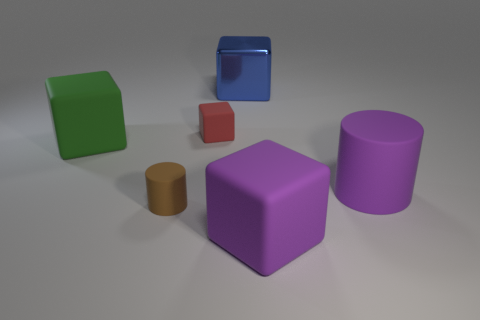What materials do the objects appear to be made from? The objects in the image seem to have different materials. The green and the red cubes have a matte finish suggesting a solid, possibly plastic or painted wooden material. The blue cube has a transparent, glass-like appearance. The cylinders and the purple cube appear to have a matte, non-reflective surface, also indicative of a solid material, such as plastic or painted metal. 